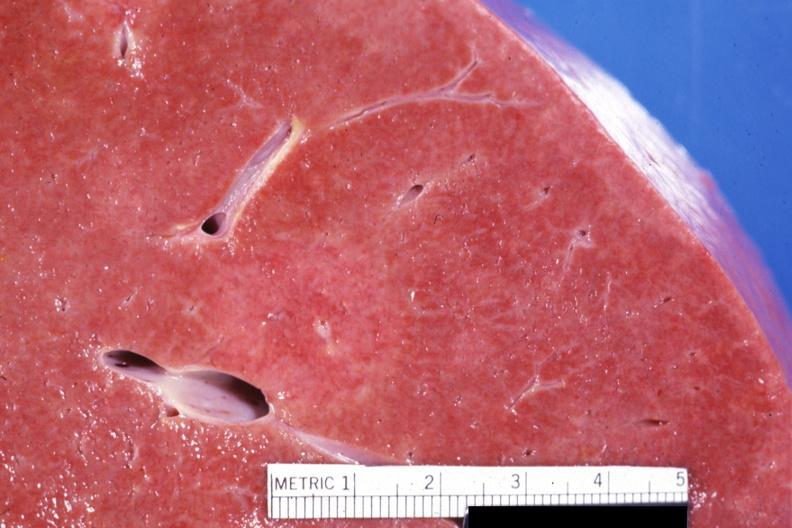re x-ray intramyocardial arteries visible?
Answer the question using a single word or phrase. No 